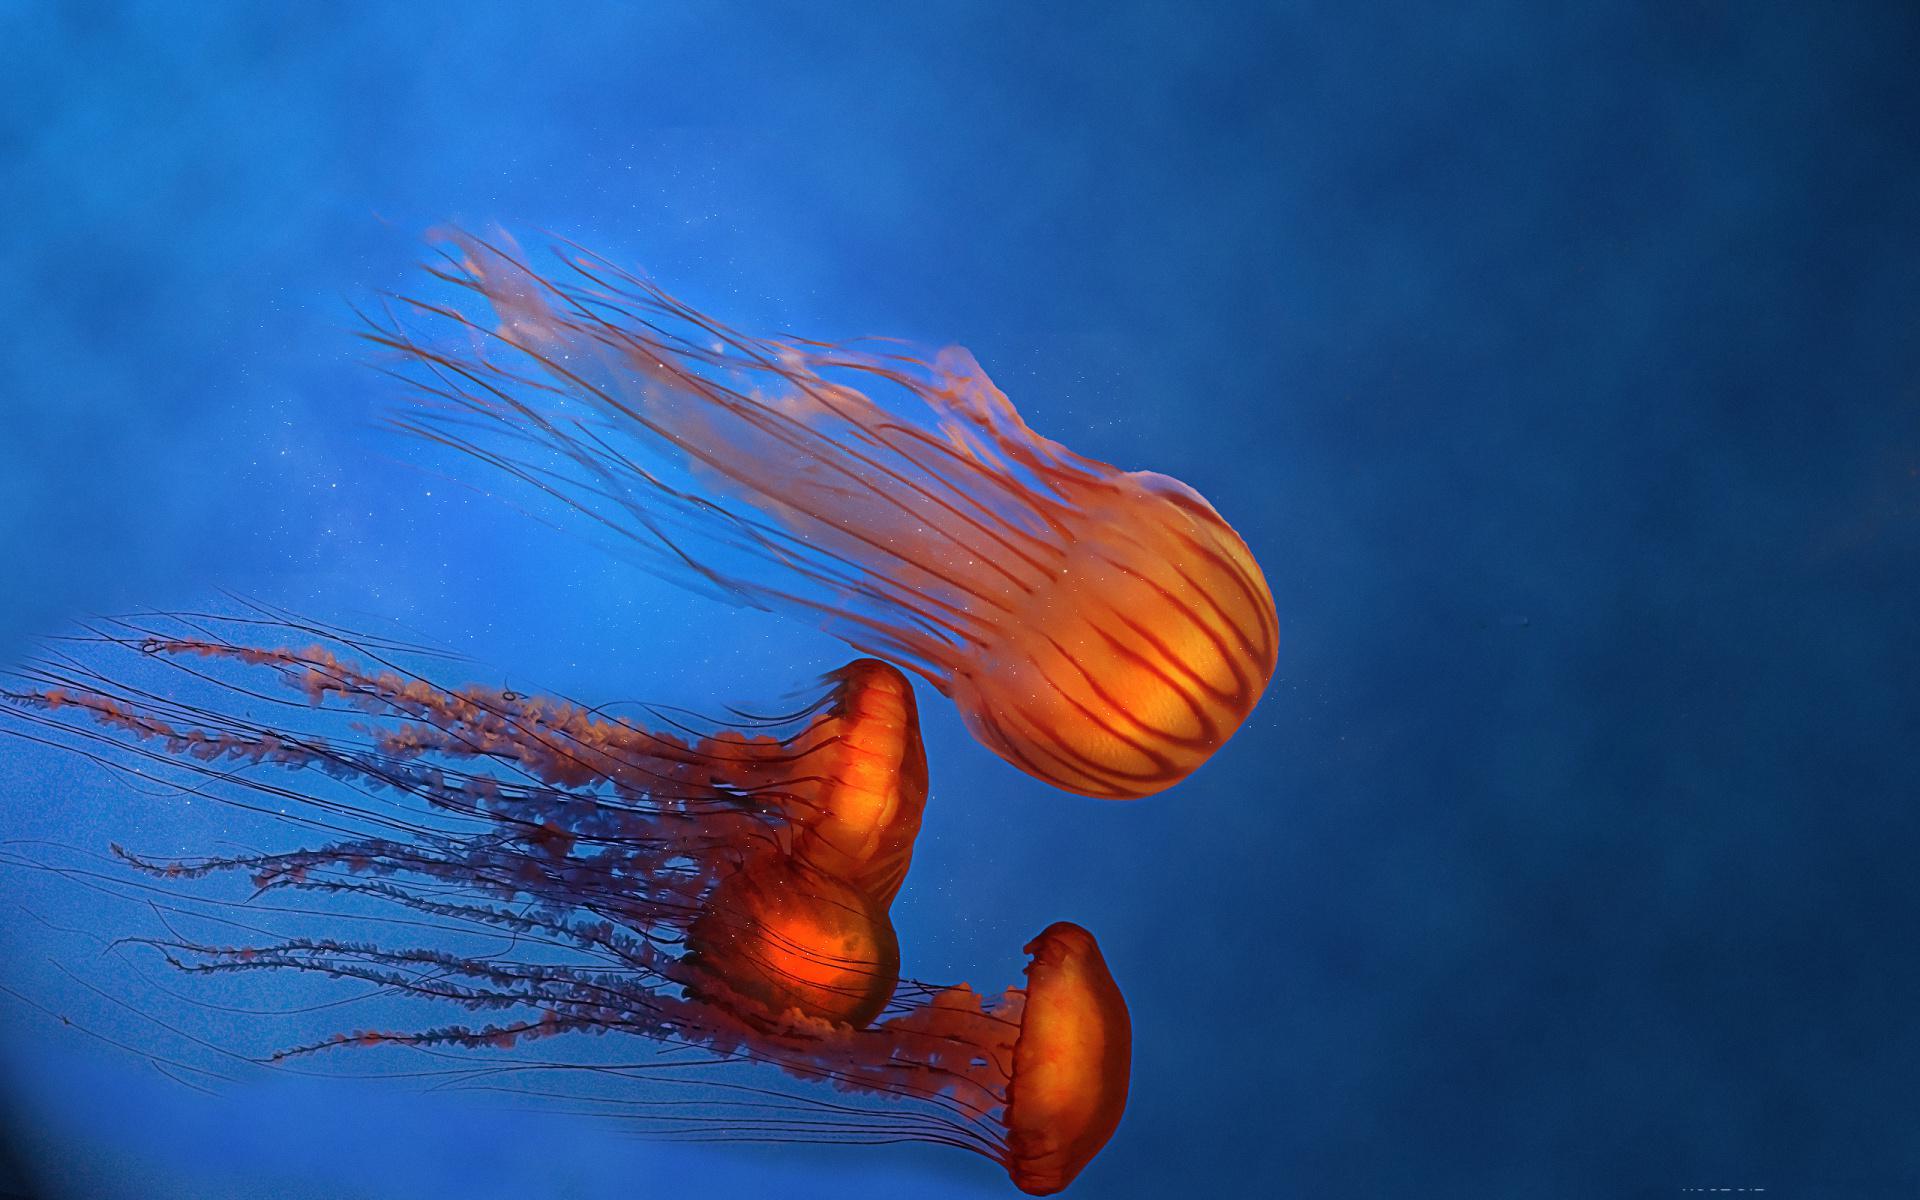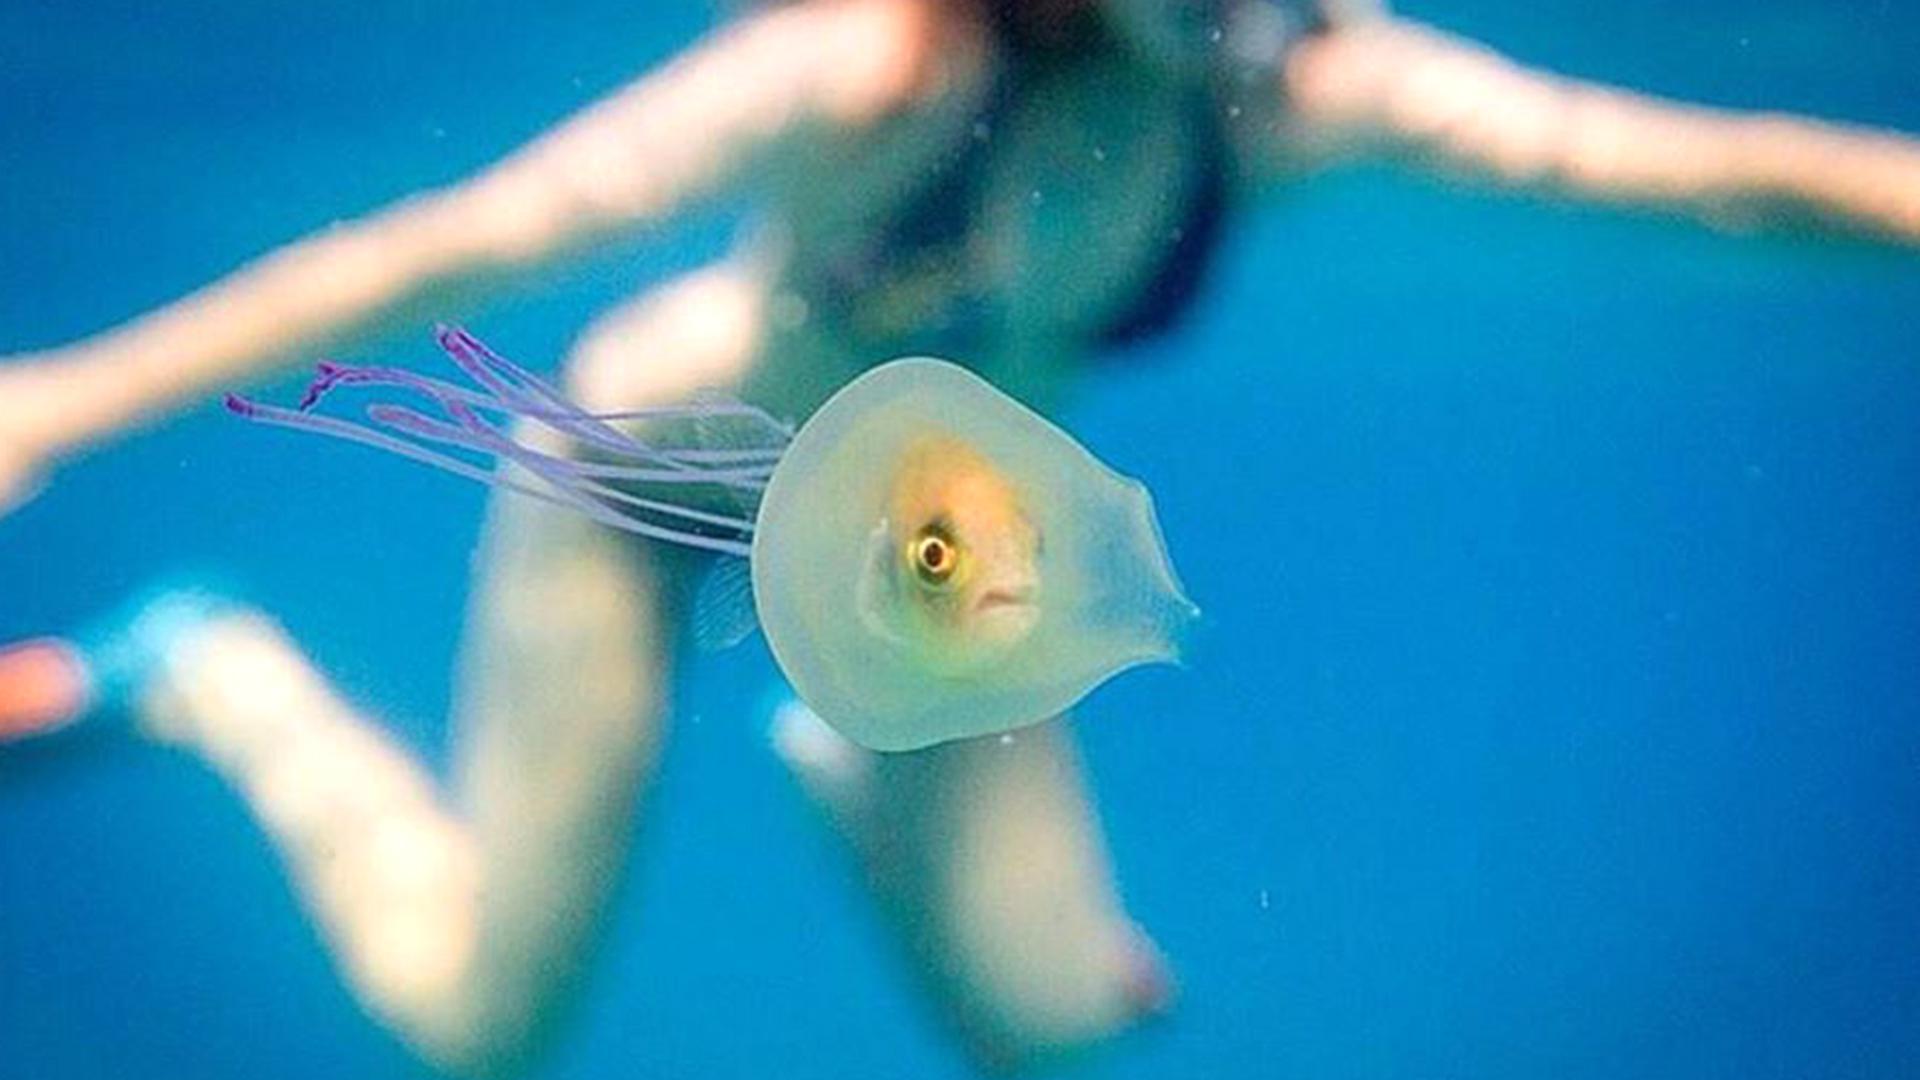The first image is the image on the left, the second image is the image on the right. Considering the images on both sides, is "The left image includes at least one orange jellyfish with long tentacles, and the right image features a fish visible inside a translucent jellyfish." valid? Answer yes or no. Yes. The first image is the image on the left, the second image is the image on the right. Considering the images on both sides, is "One of the images shows one jellyfish with a fish inside and nothing else." valid? Answer yes or no. No. 